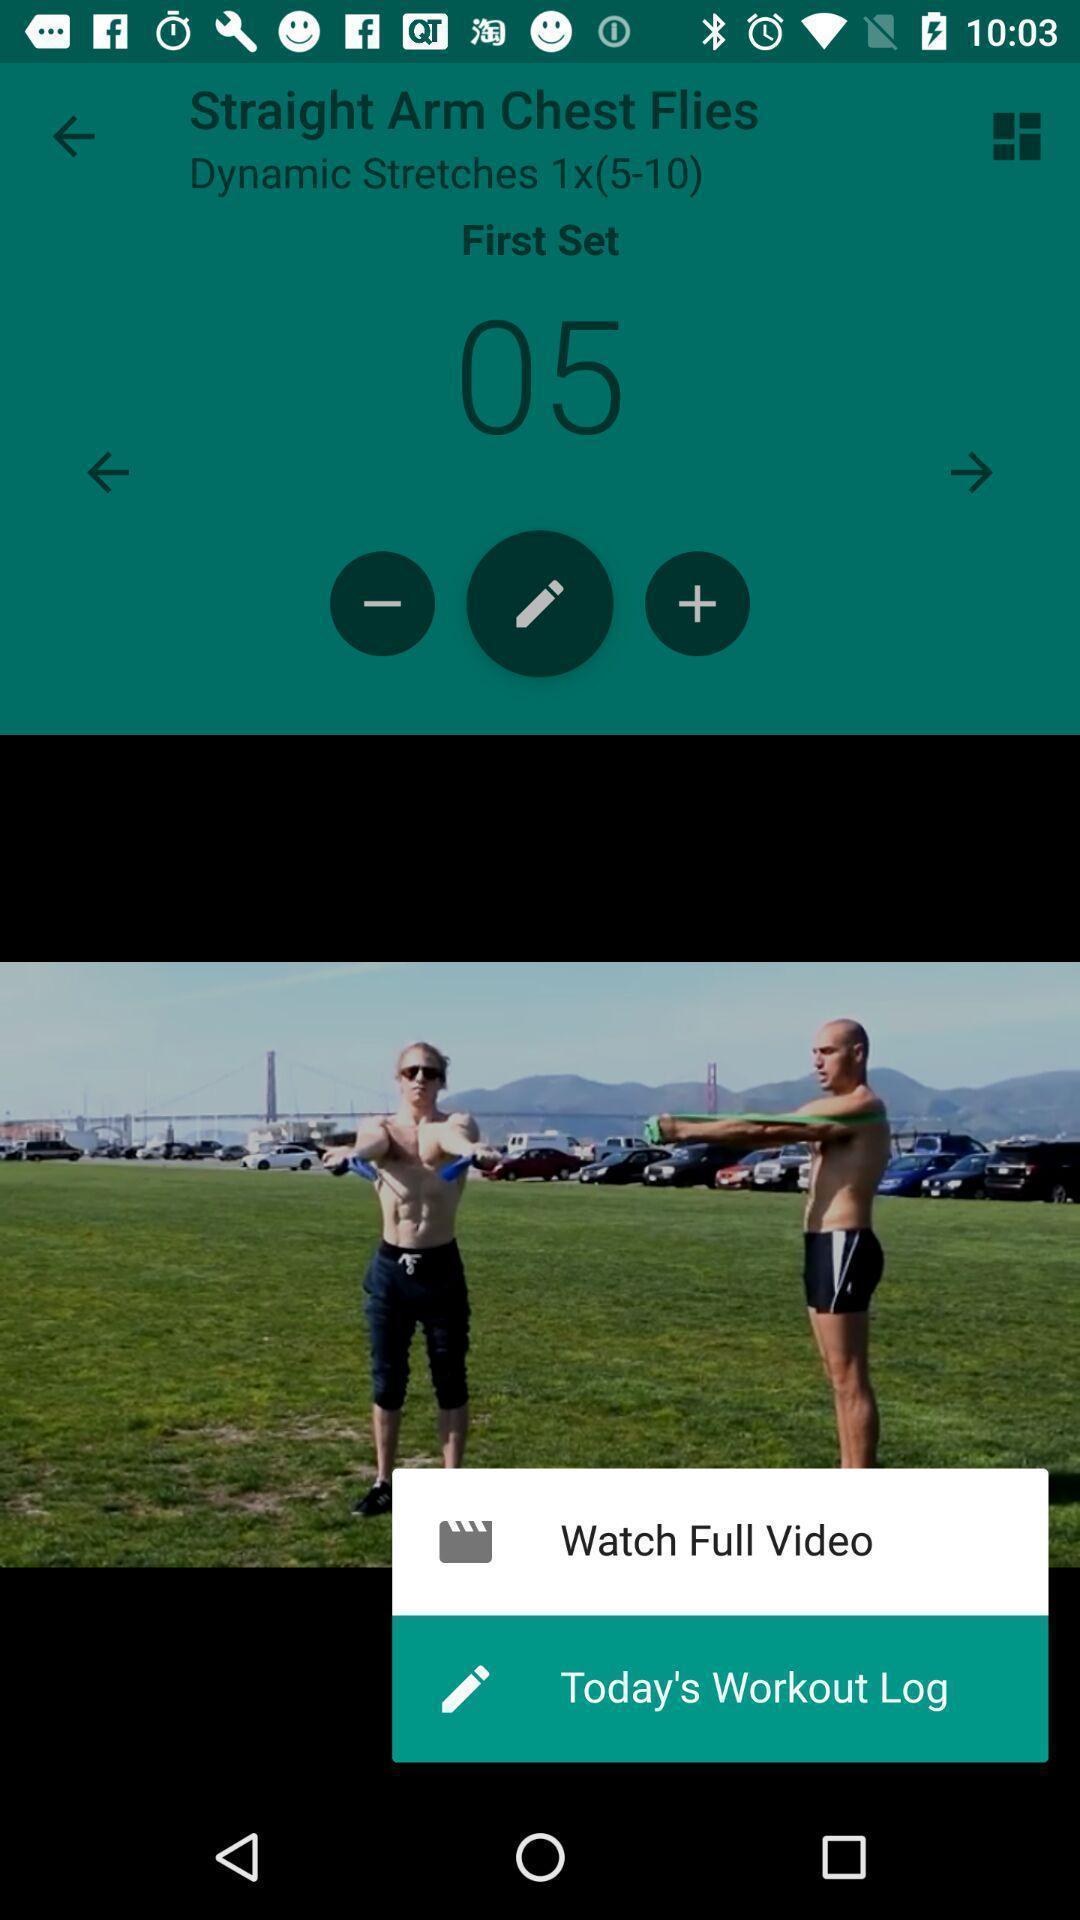Please provide a description for this image. Widget is displaying two features for workouts. 